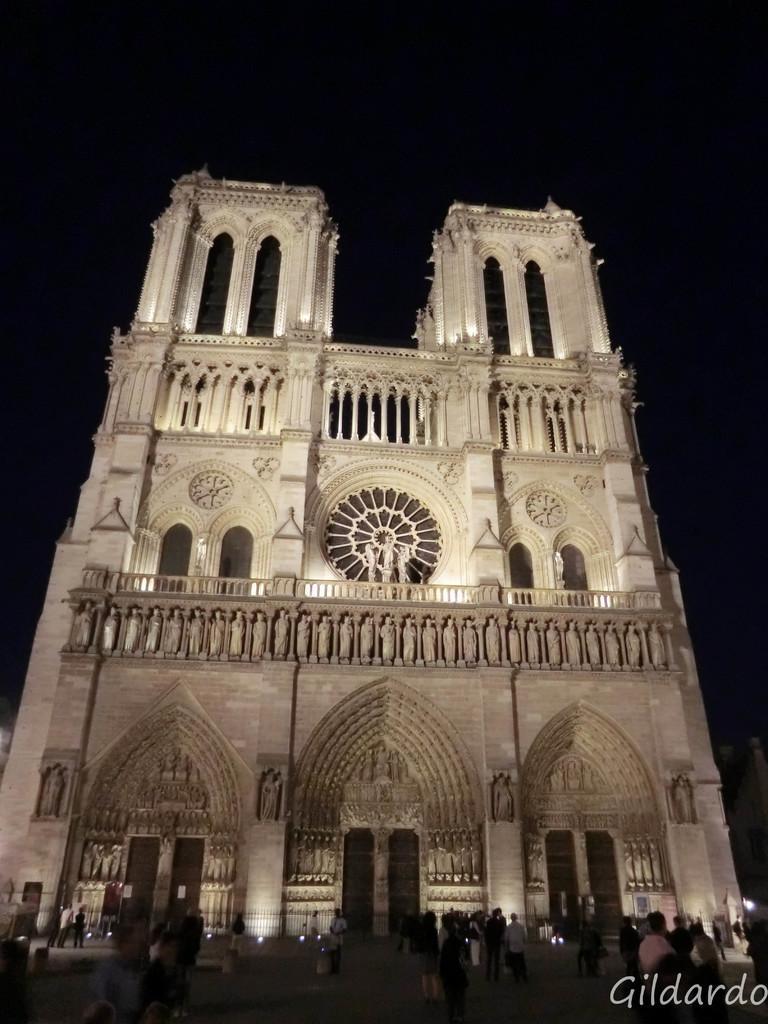In one or two sentences, can you explain what this image depicts? In the middle of the image we can see a building. In the background of the image we can see sky and persons standing on the floor in the foreground. 